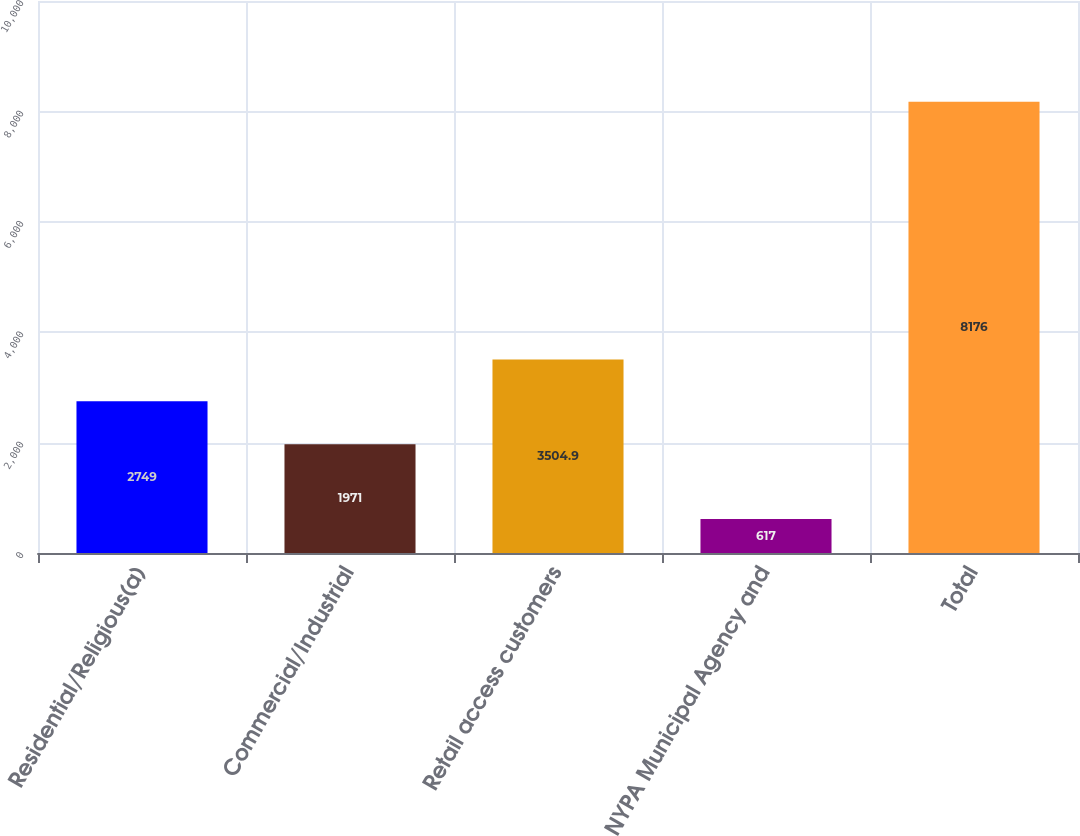Convert chart. <chart><loc_0><loc_0><loc_500><loc_500><bar_chart><fcel>Residential/Religious(a)<fcel>Commercial/Industrial<fcel>Retail access customers<fcel>NYPA Municipal Agency and<fcel>Total<nl><fcel>2749<fcel>1971<fcel>3504.9<fcel>617<fcel>8176<nl></chart> 